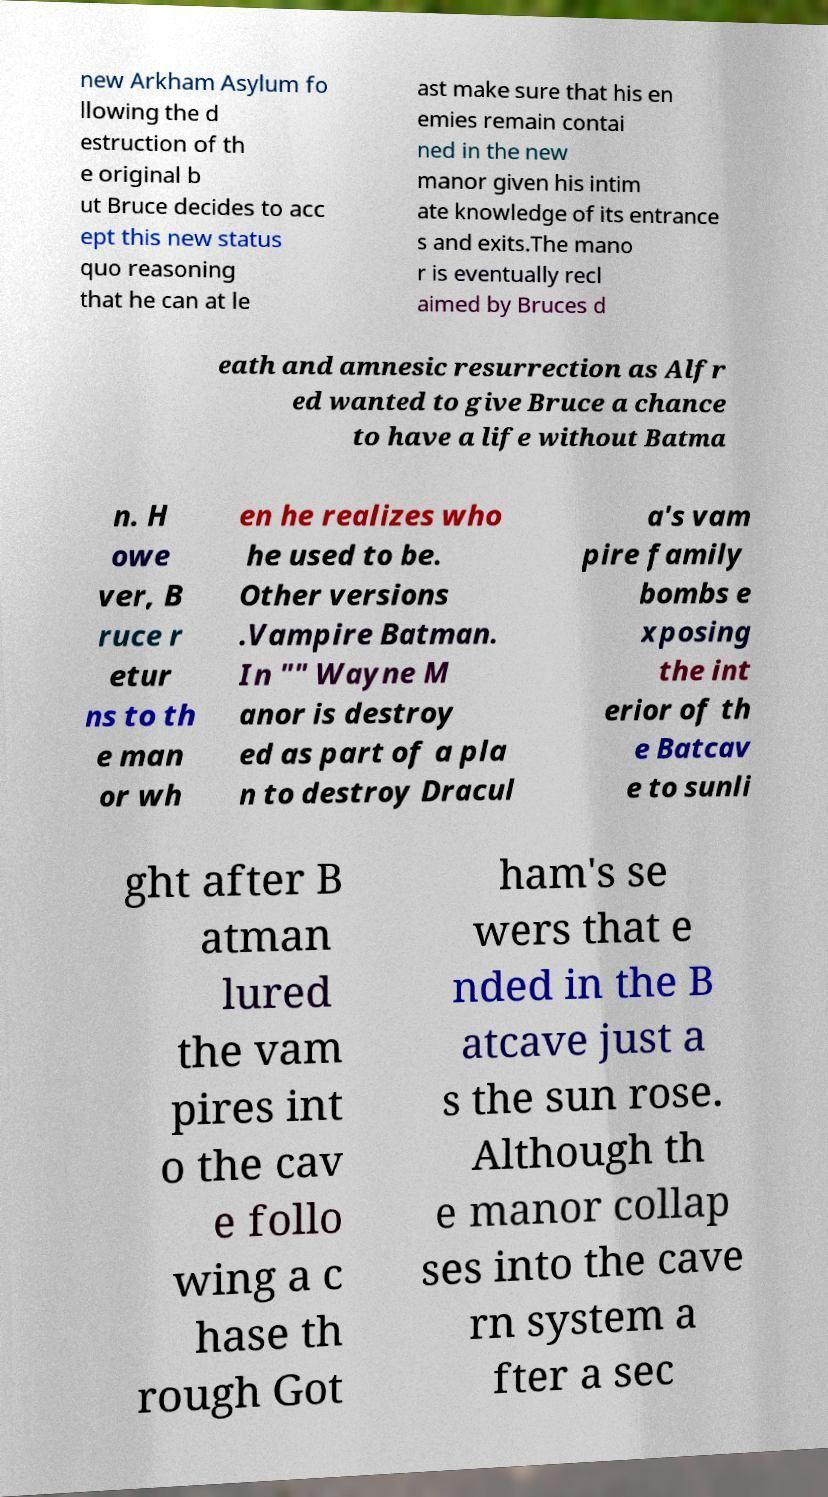Can you read and provide the text displayed in the image?This photo seems to have some interesting text. Can you extract and type it out for me? new Arkham Asylum fo llowing the d estruction of th e original b ut Bruce decides to acc ept this new status quo reasoning that he can at le ast make sure that his en emies remain contai ned in the new manor given his intim ate knowledge of its entrance s and exits.The mano r is eventually recl aimed by Bruces d eath and amnesic resurrection as Alfr ed wanted to give Bruce a chance to have a life without Batma n. H owe ver, B ruce r etur ns to th e man or wh en he realizes who he used to be. Other versions .Vampire Batman. In "" Wayne M anor is destroy ed as part of a pla n to destroy Dracul a's vam pire family bombs e xposing the int erior of th e Batcav e to sunli ght after B atman lured the vam pires int o the cav e follo wing a c hase th rough Got ham's se wers that e nded in the B atcave just a s the sun rose. Although th e manor collap ses into the cave rn system a fter a sec 